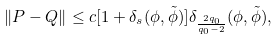<formula> <loc_0><loc_0><loc_500><loc_500>\| P - Q \| \leq c [ 1 + \delta _ { s } ( \phi , \tilde { \phi } ) ] \delta _ { \frac { 2 q _ { 0 } } { q _ { 0 } - 2 } } ( \phi , \tilde { \phi } ) ,</formula> 